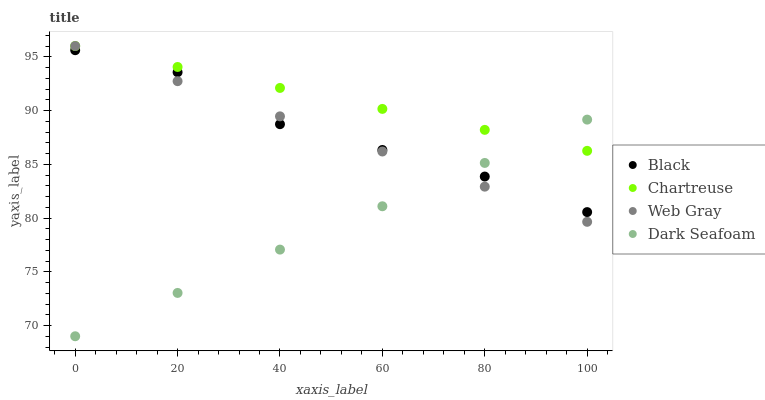Does Dark Seafoam have the minimum area under the curve?
Answer yes or no. Yes. Does Chartreuse have the maximum area under the curve?
Answer yes or no. Yes. Does Web Gray have the minimum area under the curve?
Answer yes or no. No. Does Web Gray have the maximum area under the curve?
Answer yes or no. No. Is Chartreuse the smoothest?
Answer yes or no. Yes. Is Black the roughest?
Answer yes or no. Yes. Is Web Gray the smoothest?
Answer yes or no. No. Is Web Gray the roughest?
Answer yes or no. No. Does Dark Seafoam have the lowest value?
Answer yes or no. Yes. Does Web Gray have the lowest value?
Answer yes or no. No. Does Web Gray have the highest value?
Answer yes or no. Yes. Does Black have the highest value?
Answer yes or no. No. Is Black less than Chartreuse?
Answer yes or no. Yes. Is Chartreuse greater than Black?
Answer yes or no. Yes. Does Web Gray intersect Chartreuse?
Answer yes or no. Yes. Is Web Gray less than Chartreuse?
Answer yes or no. No. Is Web Gray greater than Chartreuse?
Answer yes or no. No. Does Black intersect Chartreuse?
Answer yes or no. No. 